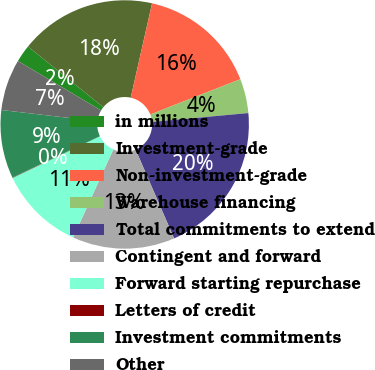<chart> <loc_0><loc_0><loc_500><loc_500><pie_chart><fcel>in millions<fcel>Investment-grade<fcel>Non-investment-grade<fcel>Warehouse financing<fcel>Total commitments to extend<fcel>Contingent and forward<fcel>Forward starting repurchase<fcel>Letters of credit<fcel>Investment commitments<fcel>Other<nl><fcel>2.26%<fcel>17.74%<fcel>15.53%<fcel>4.47%<fcel>19.95%<fcel>13.32%<fcel>11.11%<fcel>0.05%<fcel>8.89%<fcel>6.68%<nl></chart> 